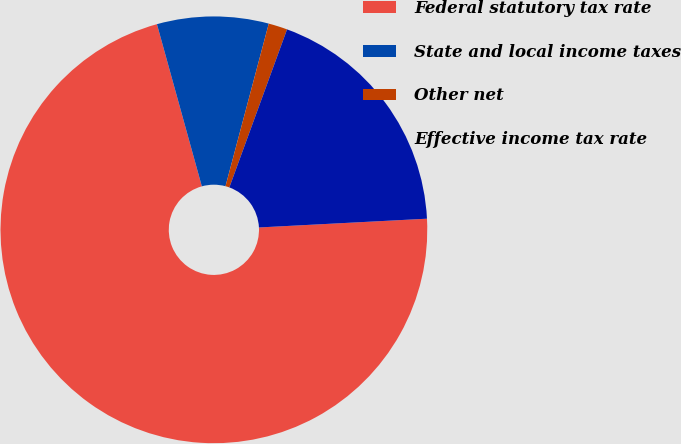Convert chart to OTSL. <chart><loc_0><loc_0><loc_500><loc_500><pie_chart><fcel>Federal statutory tax rate<fcel>State and local income taxes<fcel>Other net<fcel>Effective income tax rate<nl><fcel>71.53%<fcel>8.44%<fcel>1.43%<fcel>18.6%<nl></chart> 